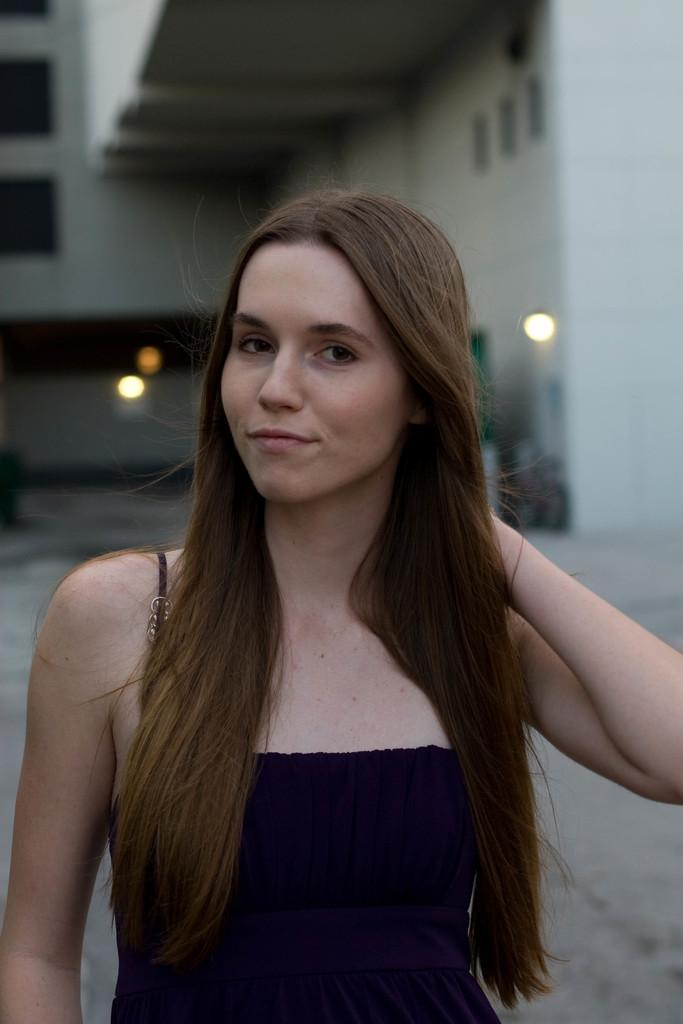Who is present in the image? There is a woman in the image. What is the woman doing in the image? The woman is standing and smiling. What can be seen in the background of the image? There is a building and lights visible in the background. How is the background of the image depicted? The background of the image is blurred. What color is the shirt the woman is wearing in the image? The provided facts do not mention the color of the woman's shirt, so we cannot determine the color from the image. How many mice can be seen running around in the image? There are no mice present in the image. 